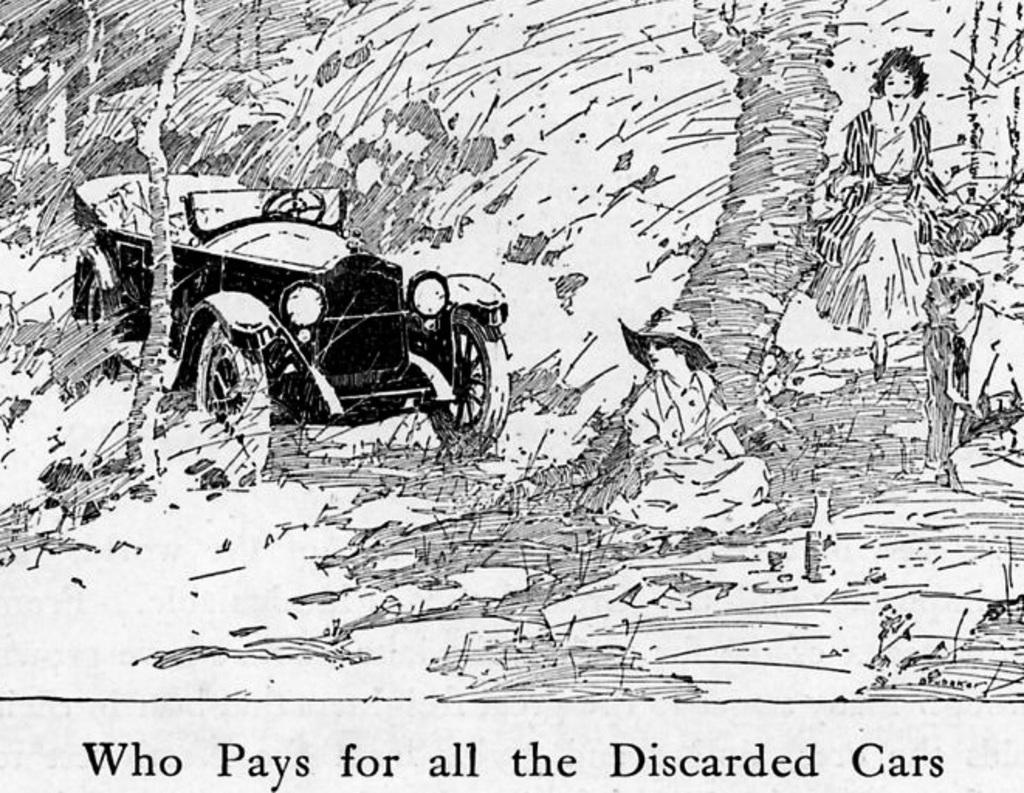What vehicle is depicted in the sketch? There is a jeep in the sketch. Where is the jeep located in the sketch? The jeep is on the left side of the sketch. Who is present in the sketch besides the jeep? There is a person sitting in the sketch. Where is the person sitting in the sketch? The person is in the middle of the sketch. What action is being performed by another character in the sketch? There is a girl walking in the sketch. Where is the girl walking in the sketch? The girl is on the right side of the sketch. What type of church can be seen in the background of the sketch? There is no church present in the sketch; it only features a jeep, a person sitting, and a girl walking. 